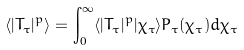<formula> <loc_0><loc_0><loc_500><loc_500>\langle | T _ { \tau } | ^ { p } \rangle = \int _ { 0 } ^ { \infty } \langle | T _ { \tau } | ^ { p } | \chi _ { \tau } \rangle P _ { \tau } ( \chi _ { \tau } ) d \chi _ { \tau }</formula> 